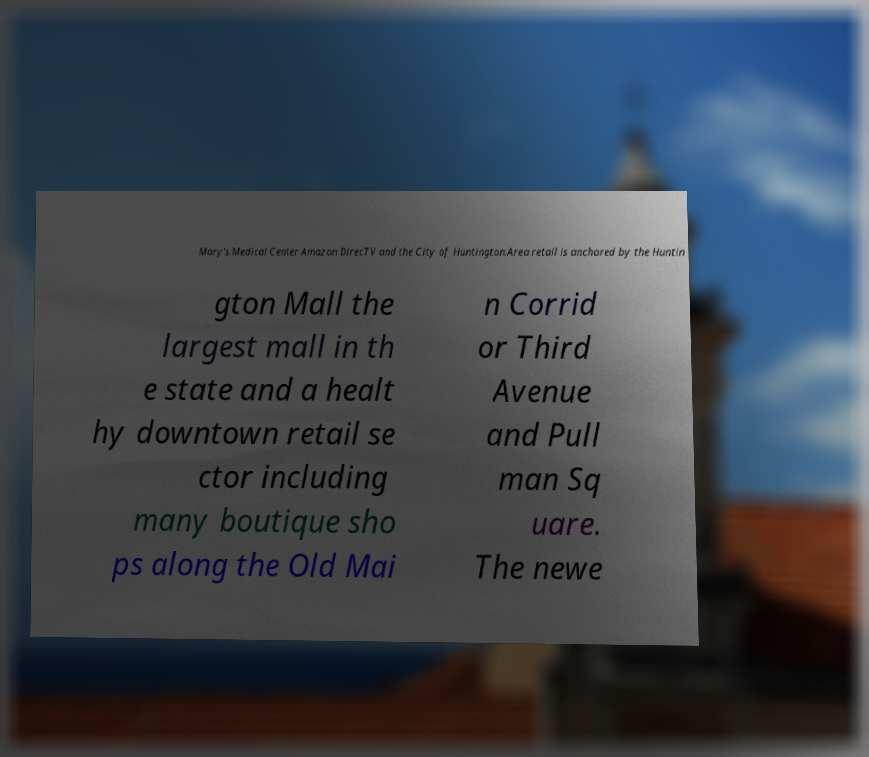There's text embedded in this image that I need extracted. Can you transcribe it verbatim? Mary's Medical Center Amazon DirecTV and the City of Huntington.Area retail is anchored by the Huntin gton Mall the largest mall in th e state and a healt hy downtown retail se ctor including many boutique sho ps along the Old Mai n Corrid or Third Avenue and Pull man Sq uare. The newe 